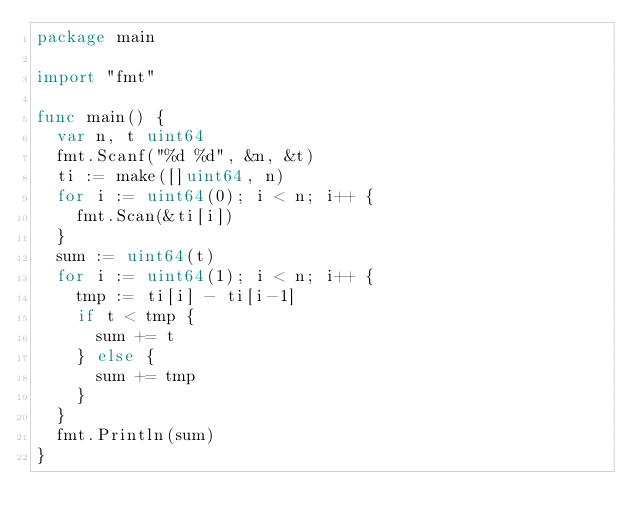Convert code to text. <code><loc_0><loc_0><loc_500><loc_500><_Go_>package main

import "fmt"

func main() {
	var n, t uint64
	fmt.Scanf("%d %d", &n, &t)
	ti := make([]uint64, n)
	for i := uint64(0); i < n; i++ {
		fmt.Scan(&ti[i])
	}
	sum := uint64(t)
	for i := uint64(1); i < n; i++ {
		tmp := ti[i] - ti[i-1]
		if t < tmp {
			sum += t
		} else {
			sum += tmp
		}
	}
	fmt.Println(sum)
}
</code> 